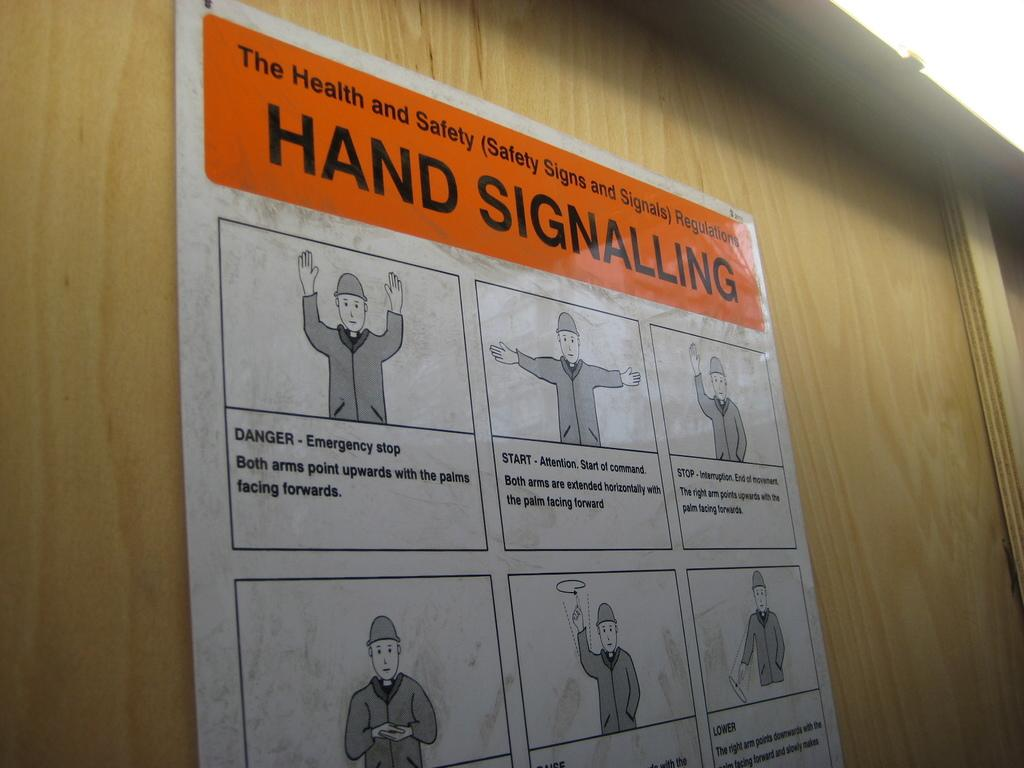Provide a one-sentence caption for the provided image. Sign that shows health and safety hand signalling. 